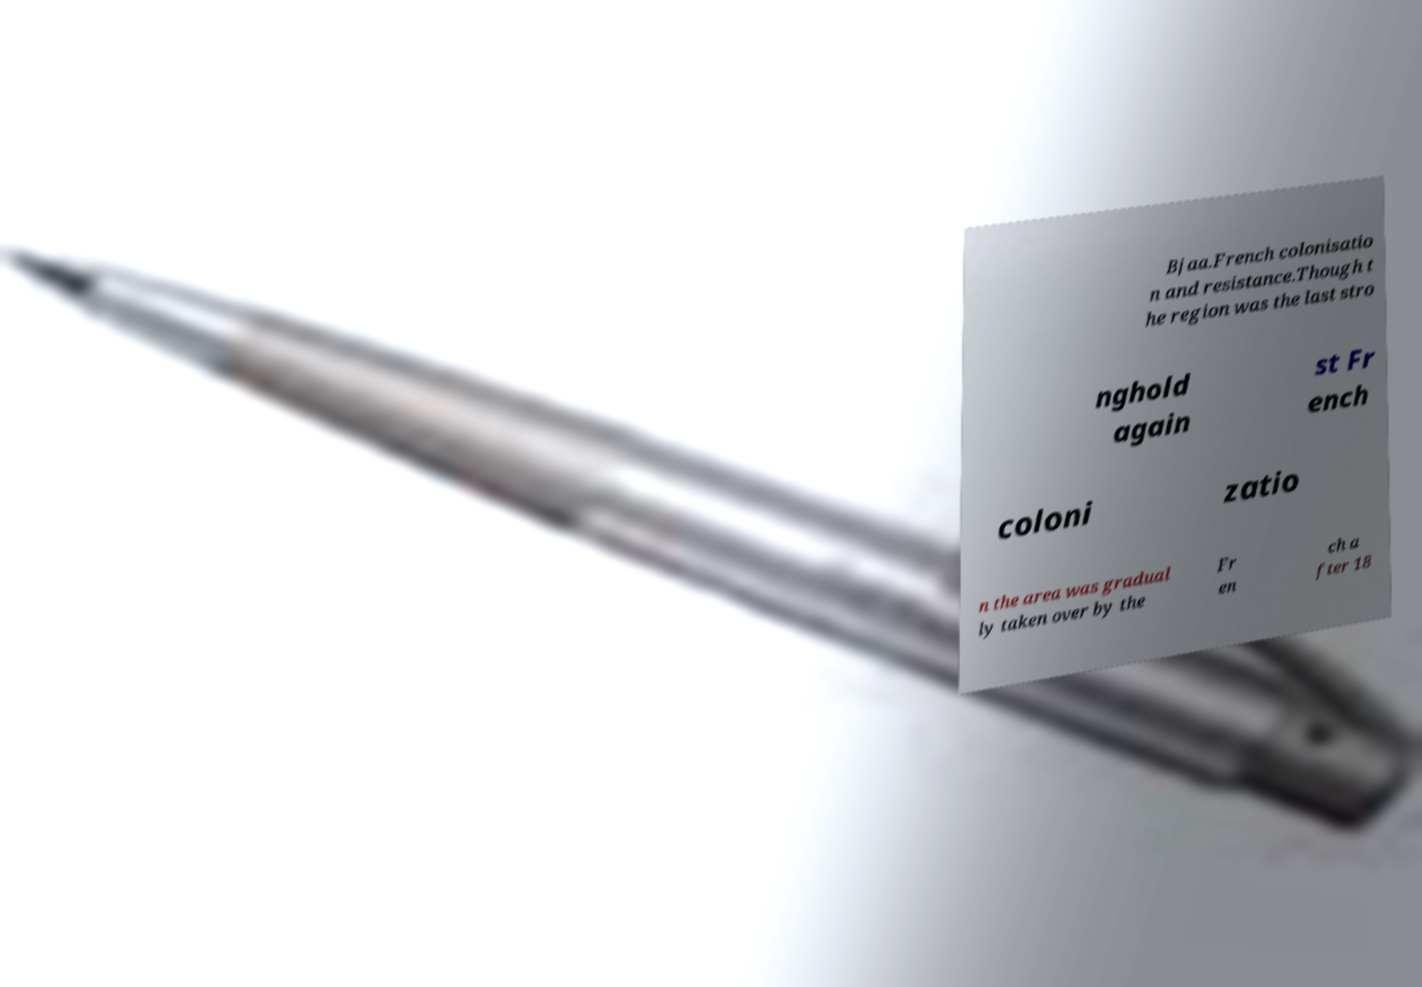Please read and relay the text visible in this image. What does it say? Bjaa.French colonisatio n and resistance.Though t he region was the last stro nghold again st Fr ench coloni zatio n the area was gradual ly taken over by the Fr en ch a fter 18 